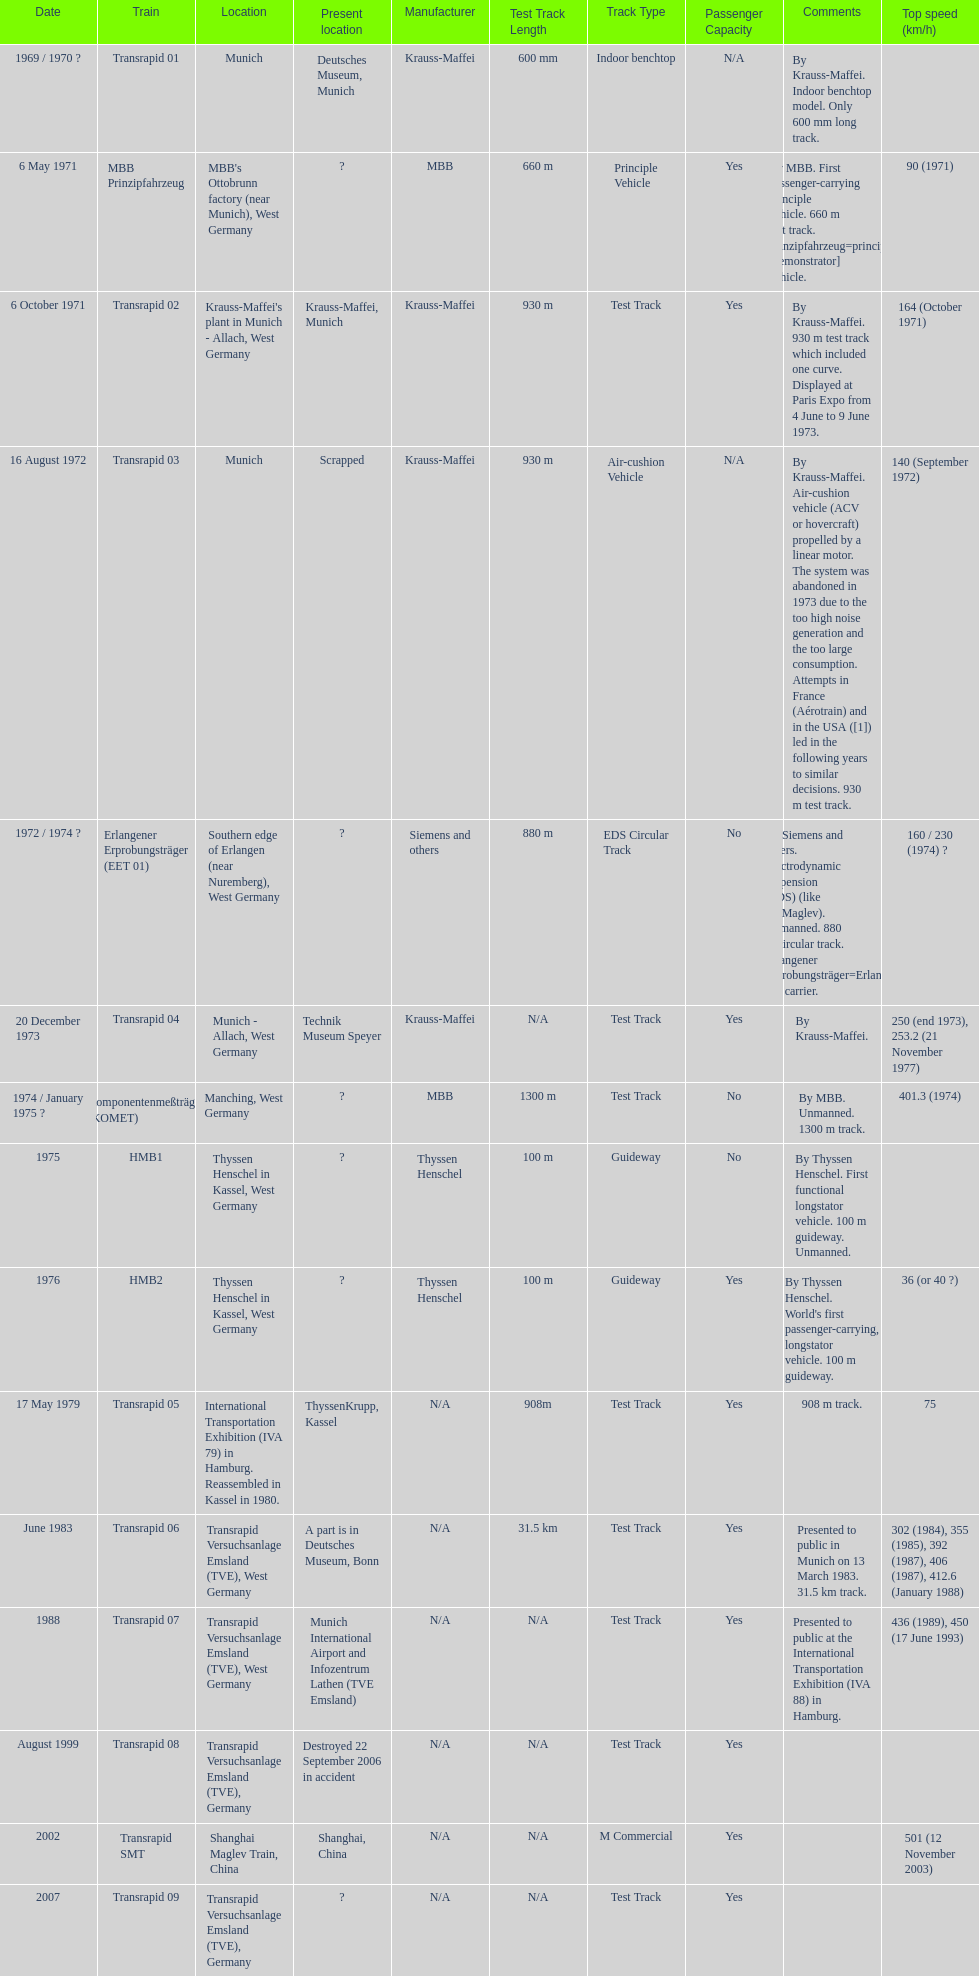How many trains other than the transrapid 07 can go faster than 450km/h? 1. 